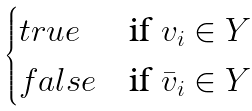<formula> <loc_0><loc_0><loc_500><loc_500>\begin{cases} t r u e & \text {if $v_{i} \in Y$} \\ f a l s e & \text {if $\bar{v}_{i} \in Y$} \end{cases}</formula> 